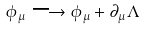Convert formula to latex. <formula><loc_0><loc_0><loc_500><loc_500>\phi _ { \mu } \longrightarrow \phi _ { \mu } + \partial _ { \mu } \Lambda</formula> 